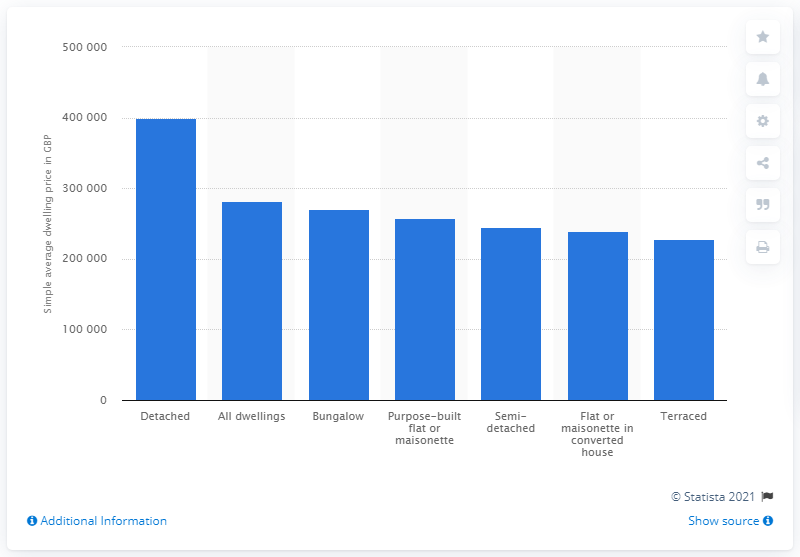Mention a couple of crucial points in this snapshot. In 2019, the average price of a detached house in the UK was 399,000. In 2019, the average price of a terraced house in the UK was approximately 228,000. 